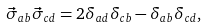<formula> <loc_0><loc_0><loc_500><loc_500>\vec { \sigma } _ { a b } \vec { \sigma } _ { c d } = 2 \delta _ { a d } \delta _ { c b } - \delta _ { a b } \delta _ { c d } ,</formula> 